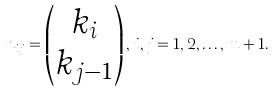Convert formula to latex. <formula><loc_0><loc_0><loc_500><loc_500>n _ { i j } = \begin{pmatrix} k _ { i } \\ k _ { j - 1 } \end{pmatrix} , \, i , j = 1 , 2 , \dots , m + 1 .</formula> 